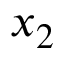Convert formula to latex. <formula><loc_0><loc_0><loc_500><loc_500>x _ { 2 }</formula> 